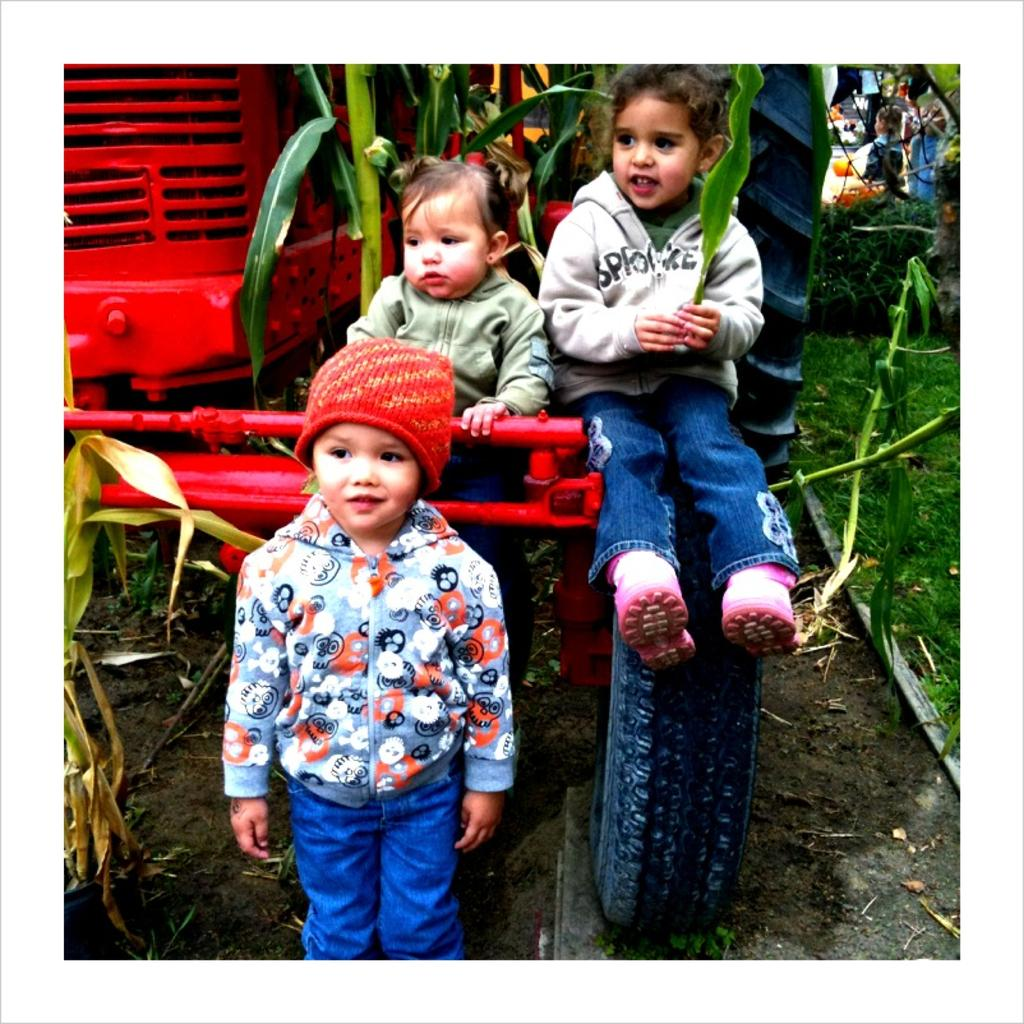How many kids are in the image? There are three small kids in the image. What are the kids doing in the image? One kid is standing, and two kids are sitting on the tractor wheel. What type of vehicle is in the image? There is a red color tractor in the image. Where is the tractor located in the image? The tractor is parked on the ground. What type of crate is being used to fight in the image? There is no crate or fighting present in the image. How many bombs can be seen on the tractor in the image? There are no bombs present in the image; it features a tractor with kids sitting on the wheel. 